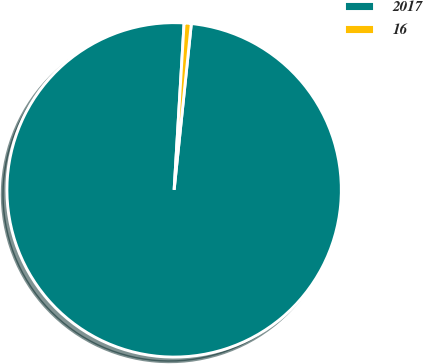<chart> <loc_0><loc_0><loc_500><loc_500><pie_chart><fcel>2017<fcel>16<nl><fcel>99.31%<fcel>0.69%<nl></chart> 